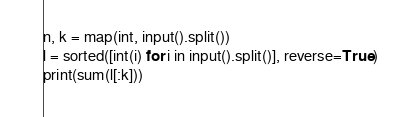Convert code to text. <code><loc_0><loc_0><loc_500><loc_500><_Python_>n, k = map(int, input().split())
l = sorted([int(i) for i in input().split()], reverse=True)
print(sum(l[:k]))</code> 